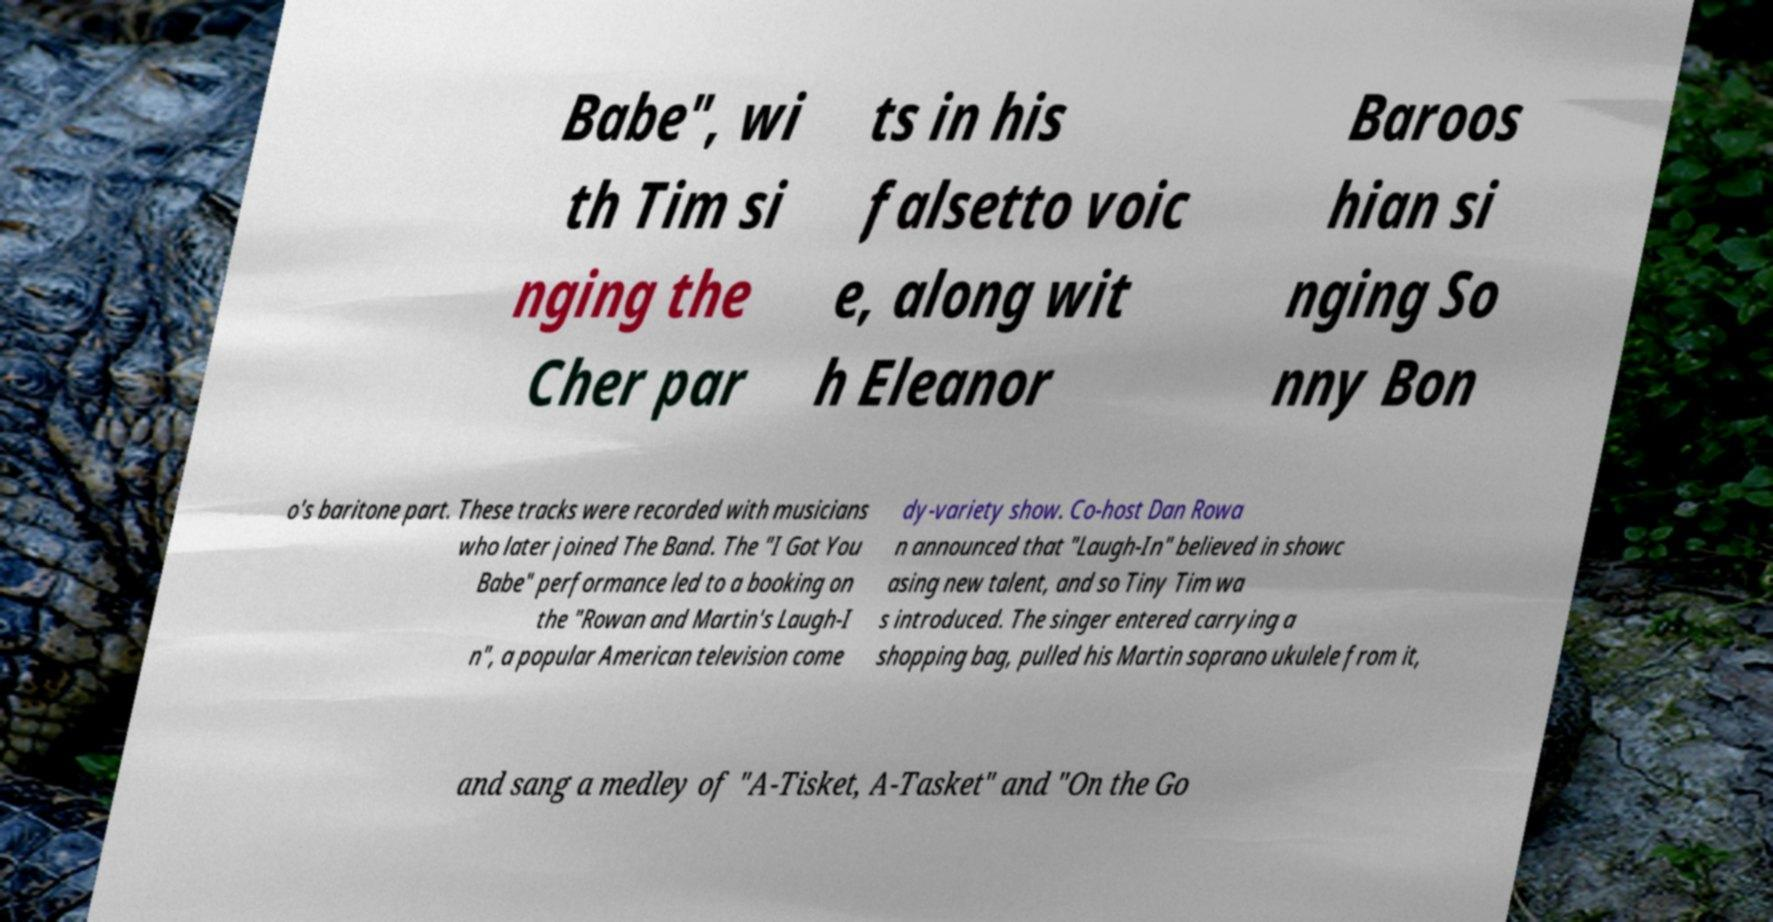Please read and relay the text visible in this image. What does it say? Babe", wi th Tim si nging the Cher par ts in his falsetto voic e, along wit h Eleanor Baroos hian si nging So nny Bon o's baritone part. These tracks were recorded with musicians who later joined The Band. The "I Got You Babe" performance led to a booking on the "Rowan and Martin's Laugh-I n", a popular American television come dy-variety show. Co-host Dan Rowa n announced that "Laugh-In" believed in showc asing new talent, and so Tiny Tim wa s introduced. The singer entered carrying a shopping bag, pulled his Martin soprano ukulele from it, and sang a medley of "A-Tisket, A-Tasket" and "On the Go 